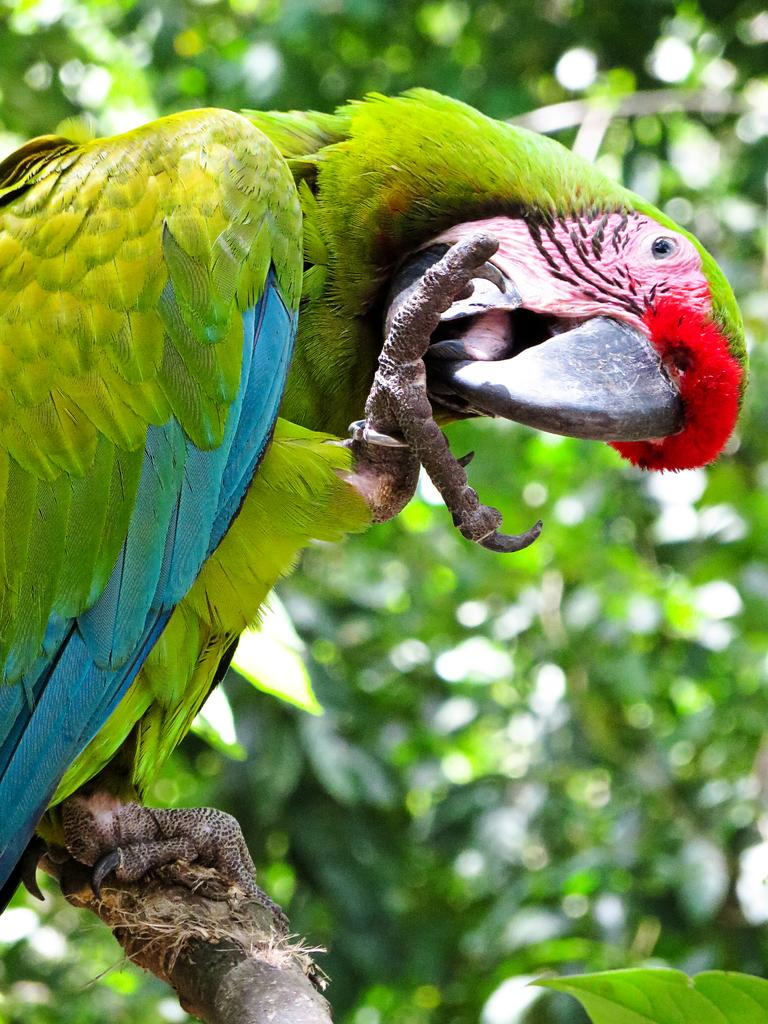What type of animal is in the image? There is a parrot in the image. Can you describe the background of the image? The background of the image is blurred. Where is the leaf located in the image? The leaf is in the bottom right corner of the image. What type of pet does the parrot need in the image? The image does not show any pets or indicate that the parrot needs anything, so it is not possible to answer that question. 